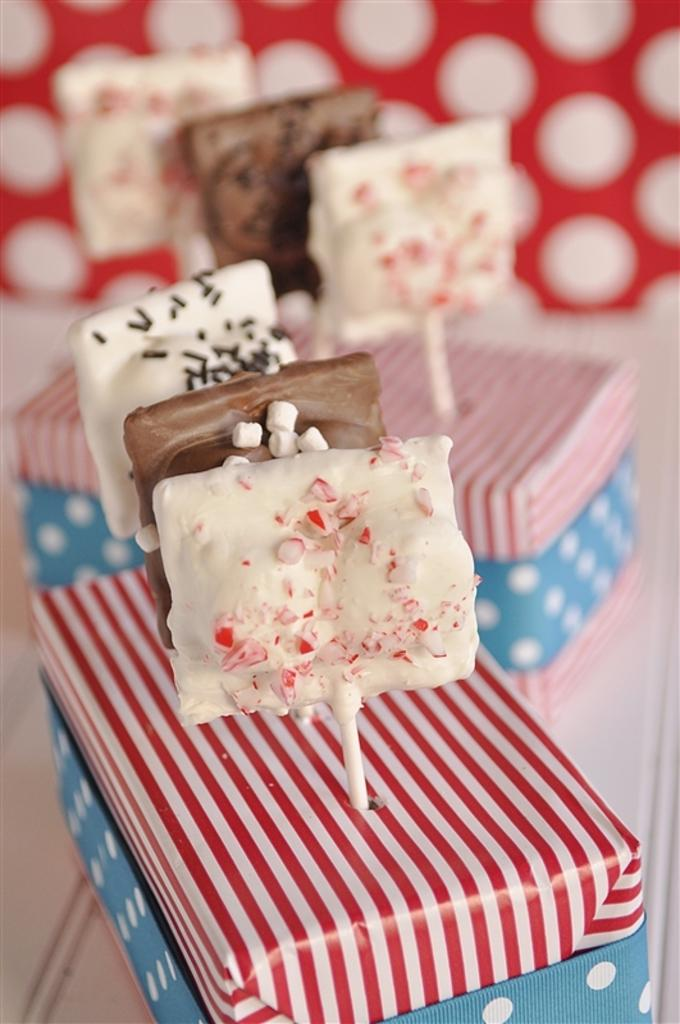What type of items are placed in a box in the image? There are candies placed in a box in the image. Can you describe the background of the image? There is another box in the backdrop of the image. What is the color and pattern of the wall in the image? The wall in the image is red with polka dots. What type of silk material is used to make the key in the image? There is no silk or key present in the image. 